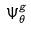<formula> <loc_0><loc_0><loc_500><loc_500>\Psi _ { \theta } ^ { g }</formula> 